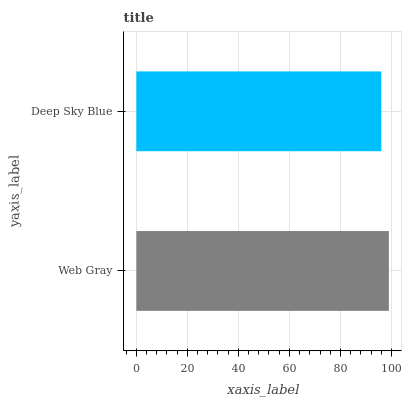Is Deep Sky Blue the minimum?
Answer yes or no. Yes. Is Web Gray the maximum?
Answer yes or no. Yes. Is Deep Sky Blue the maximum?
Answer yes or no. No. Is Web Gray greater than Deep Sky Blue?
Answer yes or no. Yes. Is Deep Sky Blue less than Web Gray?
Answer yes or no. Yes. Is Deep Sky Blue greater than Web Gray?
Answer yes or no. No. Is Web Gray less than Deep Sky Blue?
Answer yes or no. No. Is Web Gray the high median?
Answer yes or no. Yes. Is Deep Sky Blue the low median?
Answer yes or no. Yes. Is Deep Sky Blue the high median?
Answer yes or no. No. Is Web Gray the low median?
Answer yes or no. No. 